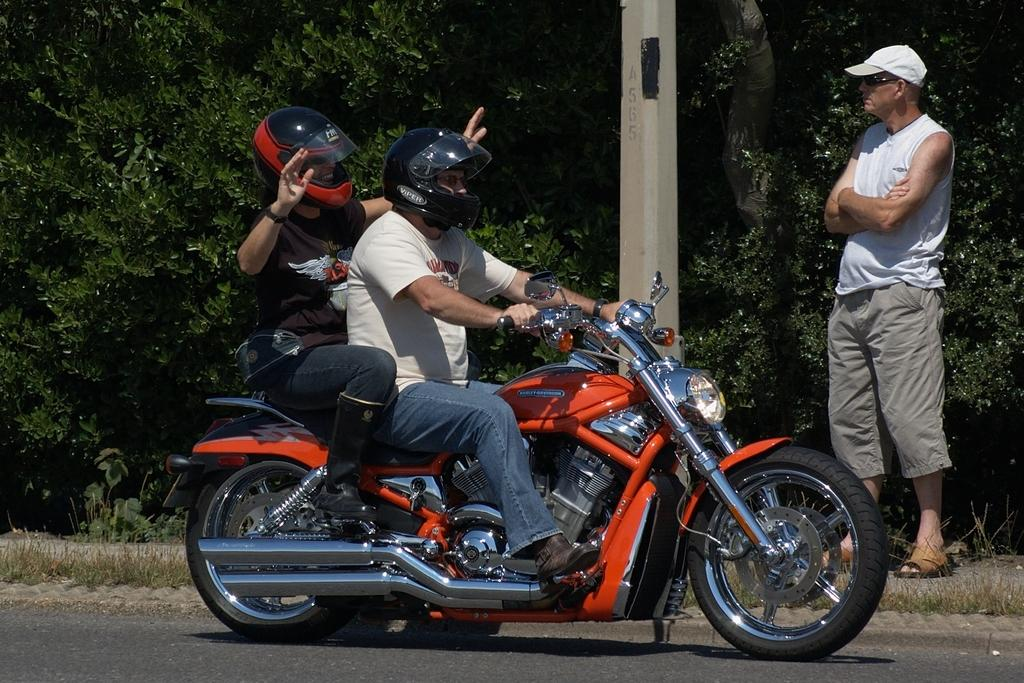What are the two people on the bike doing? The two people are sitting on a bike. What safety precaution are the people on the bike taking? The people on the bike are wearing helmets. Can you describe the person standing beside the bike? There is a person in a white shirt standing beside the bike. What can be seen in the background of the image? There is a pole and plants in the image. What type of church can be seen in the background of the image? There is no church present in the image; it features a bike with two people sitting on it, a person standing beside it, and a pole and plants in the background. What cast member from a popular TV show is standing beside the bike? There is no cast member from a TV show present in the image; it only features a person in a white shirt standing beside the bike. 